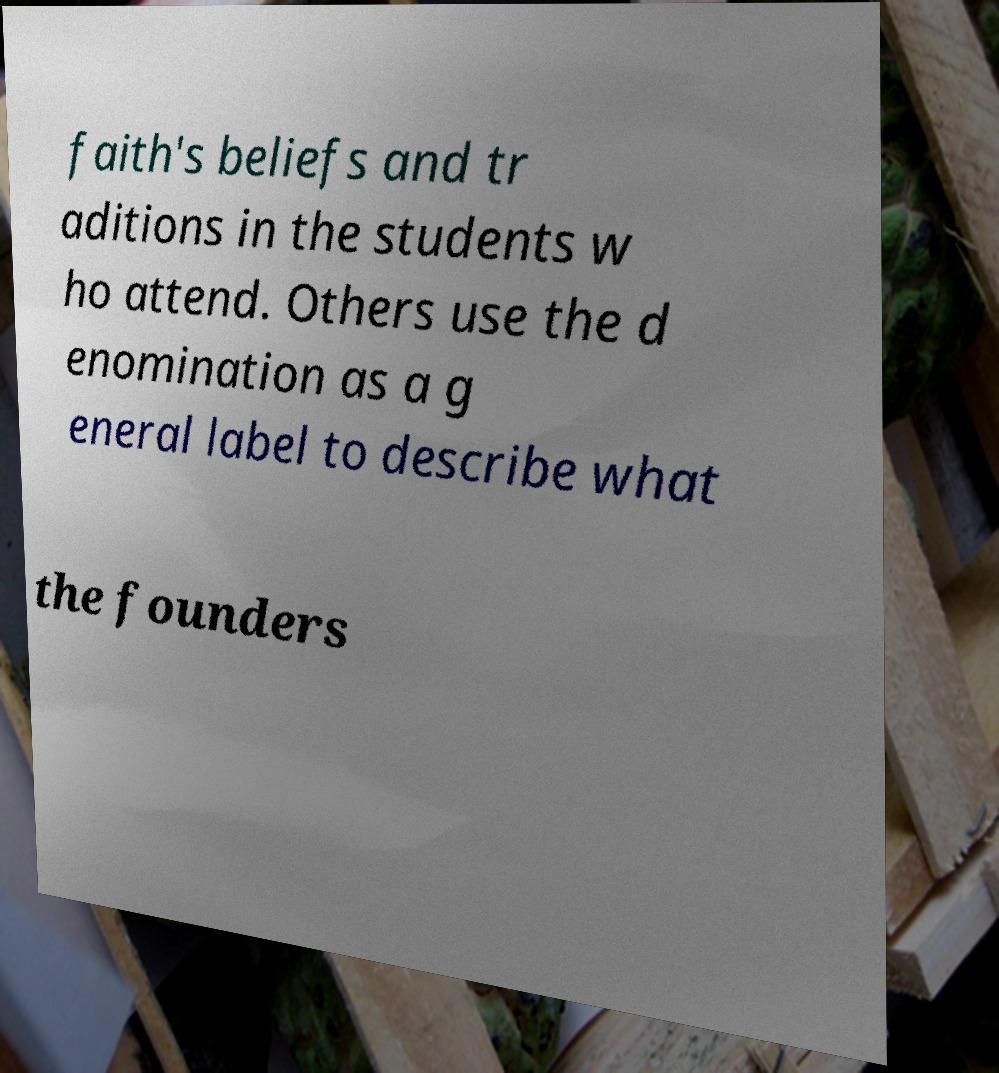Could you assist in decoding the text presented in this image and type it out clearly? faith's beliefs and tr aditions in the students w ho attend. Others use the d enomination as a g eneral label to describe what the founders 